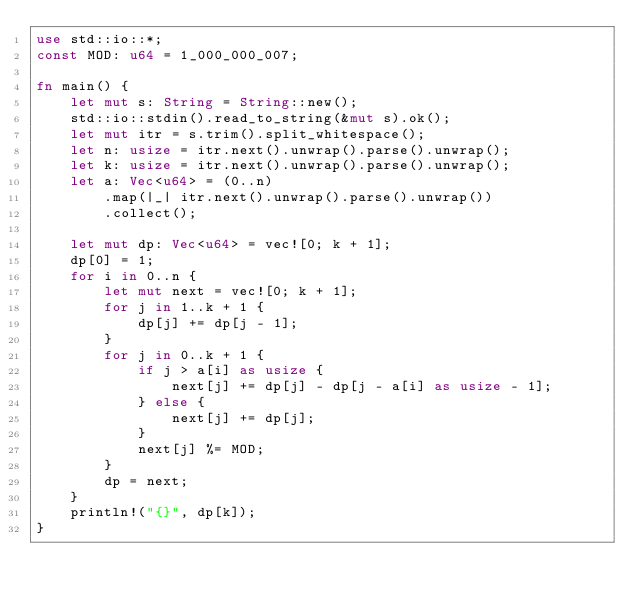Convert code to text. <code><loc_0><loc_0><loc_500><loc_500><_Rust_>use std::io::*;
const MOD: u64 = 1_000_000_007;

fn main() {
    let mut s: String = String::new();
    std::io::stdin().read_to_string(&mut s).ok();
    let mut itr = s.trim().split_whitespace();
    let n: usize = itr.next().unwrap().parse().unwrap();
    let k: usize = itr.next().unwrap().parse().unwrap();
    let a: Vec<u64> = (0..n)
        .map(|_| itr.next().unwrap().parse().unwrap())
        .collect();

    let mut dp: Vec<u64> = vec![0; k + 1];
    dp[0] = 1;
    for i in 0..n {
        let mut next = vec![0; k + 1];
        for j in 1..k + 1 {
            dp[j] += dp[j - 1];
        }
        for j in 0..k + 1 {
            if j > a[i] as usize {
                next[j] += dp[j] - dp[j - a[i] as usize - 1];
            } else {
                next[j] += dp[j];
            }
            next[j] %= MOD;
        }
        dp = next;
    }
    println!("{}", dp[k]);
}
</code> 